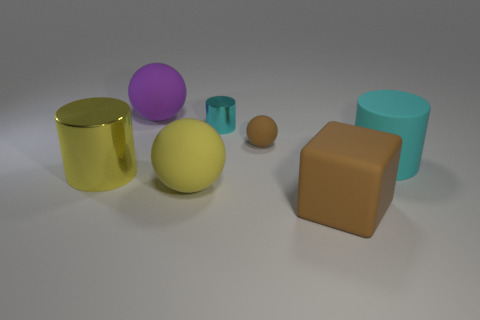Which objects stand out the most due to their size and color? The large yellow cylinder stands out prominently due to its bright color and substantial size compared to the surrounding objects. Similarly, the big purple sphere attracts attention with its vivid hue and sizable presence among the other shapes. 